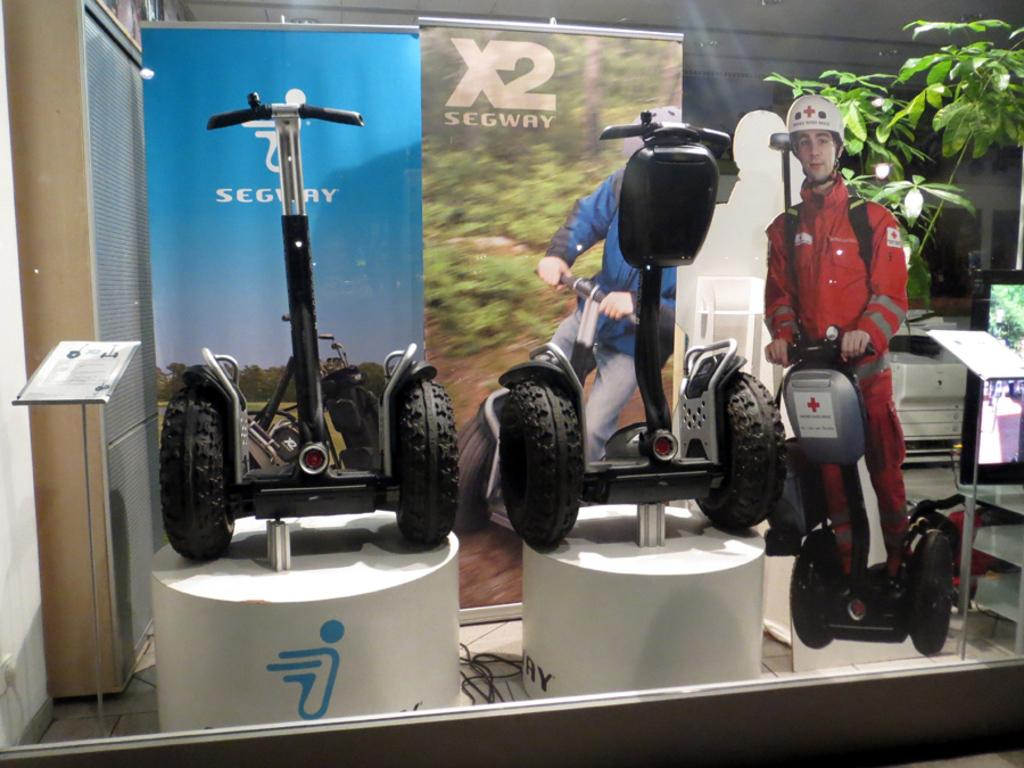What types of objects can be seen in the image? There are vehicles, information boards, a screen, hoardings, and a plant in the image. Can you describe the purpose of the information boards in the image? The information boards in the image are likely used to provide directions or details about the surrounding area. What is the screen in the image used for? The screen in the image might be used for displaying advertisements, announcements, or other information. How many hoardings are visible in the image? There is at least one hoarding visible in the image. What type of vegetation is present in the image? There is a plant in the image. What type of bit is being used to sort the roots in the image? There is no bit or root sorting activity present in the image. 